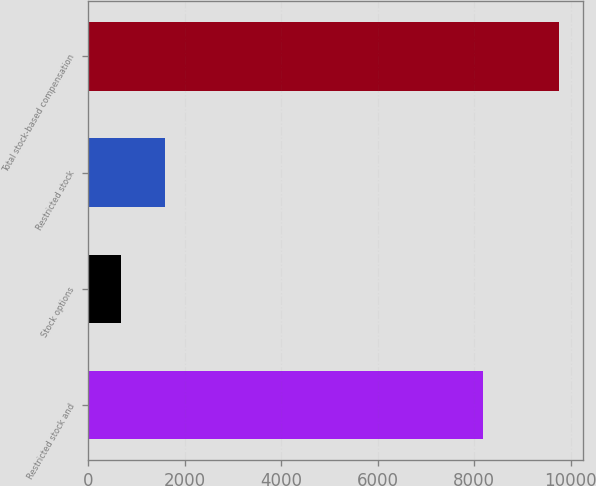<chart> <loc_0><loc_0><loc_500><loc_500><bar_chart><fcel>Restricted stock and<fcel>Stock options<fcel>Restricted stock<fcel>Total stock-based compensation<nl><fcel>8193<fcel>676<fcel>1585.3<fcel>9769<nl></chart> 